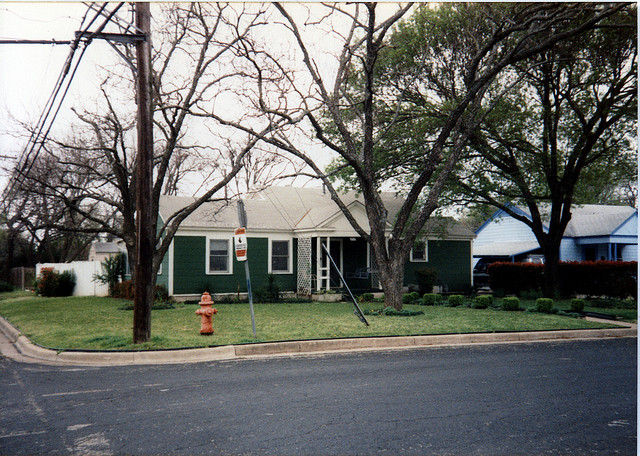Are there any signs of life or activity in or around the house? No individuals are visible in the image, and the house itself shows no obvious signs of activity. The closed curtains and lack of vehicles or outdoor items indicate that there may not be anyone at home, or that the residents are indoors without engagement in outdoor activities at the time the photo was taken. 